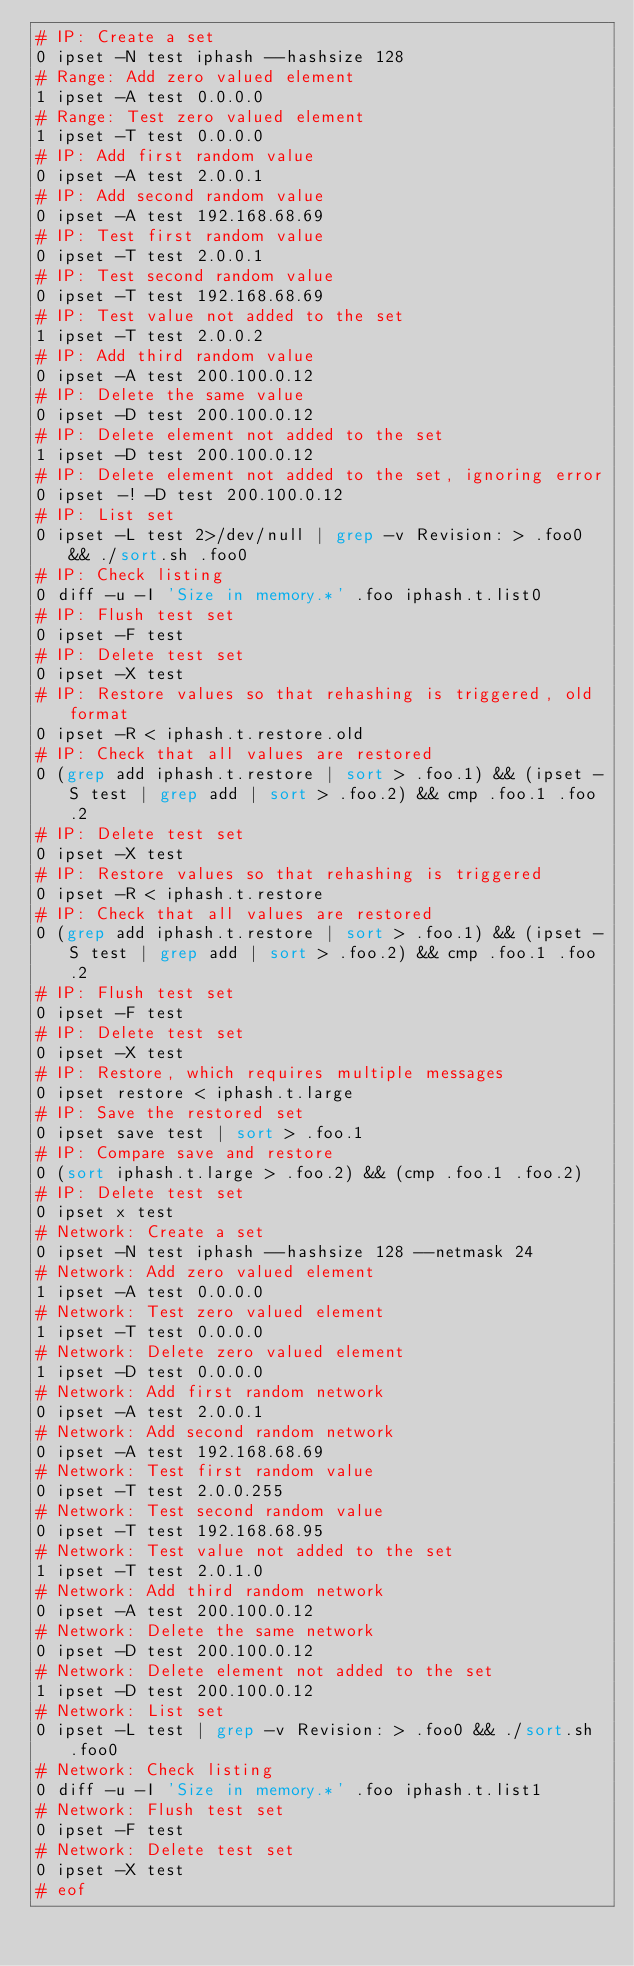Convert code to text. <code><loc_0><loc_0><loc_500><loc_500><_Perl_># IP: Create a set
0 ipset -N test iphash --hashsize 128
# Range: Add zero valued element
1 ipset -A test 0.0.0.0
# Range: Test zero valued element
1 ipset -T test 0.0.0.0
# IP: Add first random value
0 ipset -A test 2.0.0.1
# IP: Add second random value
0 ipset -A test 192.168.68.69
# IP: Test first random value
0 ipset -T test 2.0.0.1
# IP: Test second random value
0 ipset -T test 192.168.68.69
# IP: Test value not added to the set
1 ipset -T test 2.0.0.2
# IP: Add third random value
0 ipset -A test 200.100.0.12
# IP: Delete the same value
0 ipset -D test 200.100.0.12
# IP: Delete element not added to the set
1 ipset -D test 200.100.0.12
# IP: Delete element not added to the set, ignoring error
0 ipset -! -D test 200.100.0.12
# IP: List set
0 ipset -L test 2>/dev/null | grep -v Revision: > .foo0 && ./sort.sh .foo0
# IP: Check listing
0 diff -u -I 'Size in memory.*' .foo iphash.t.list0
# IP: Flush test set
0 ipset -F test
# IP: Delete test set
0 ipset -X test
# IP: Restore values so that rehashing is triggered, old format
0 ipset -R < iphash.t.restore.old
# IP: Check that all values are restored
0 (grep add iphash.t.restore | sort > .foo.1) && (ipset -S test | grep add | sort > .foo.2) && cmp .foo.1 .foo.2
# IP: Delete test set
0 ipset -X test
# IP: Restore values so that rehashing is triggered
0 ipset -R < iphash.t.restore
# IP: Check that all values are restored
0 (grep add iphash.t.restore | sort > .foo.1) && (ipset -S test | grep add | sort > .foo.2) && cmp .foo.1 .foo.2
# IP: Flush test set
0 ipset -F test
# IP: Delete test set
0 ipset -X test
# IP: Restore, which requires multiple messages
0 ipset restore < iphash.t.large
# IP: Save the restored set
0 ipset save test | sort > .foo.1
# IP: Compare save and restore
0 (sort iphash.t.large > .foo.2) && (cmp .foo.1 .foo.2)
# IP: Delete test set
0 ipset x test
# Network: Create a set
0 ipset -N test iphash --hashsize 128 --netmask 24
# Network: Add zero valued element
1 ipset -A test 0.0.0.0
# Network: Test zero valued element
1 ipset -T test 0.0.0.0
# Network: Delete zero valued element
1 ipset -D test 0.0.0.0
# Network: Add first random network
0 ipset -A test 2.0.0.1
# Network: Add second random network
0 ipset -A test 192.168.68.69
# Network: Test first random value
0 ipset -T test 2.0.0.255
# Network: Test second random value
0 ipset -T test 192.168.68.95
# Network: Test value not added to the set
1 ipset -T test 2.0.1.0
# Network: Add third random network
0 ipset -A test 200.100.0.12
# Network: Delete the same network
0 ipset -D test 200.100.0.12
# Network: Delete element not added to the set
1 ipset -D test 200.100.0.12
# Network: List set
0 ipset -L test | grep -v Revision: > .foo0 && ./sort.sh .foo0
# Network: Check listing
0 diff -u -I 'Size in memory.*' .foo iphash.t.list1
# Network: Flush test set
0 ipset -F test
# Network: Delete test set
0 ipset -X test
# eof
</code> 